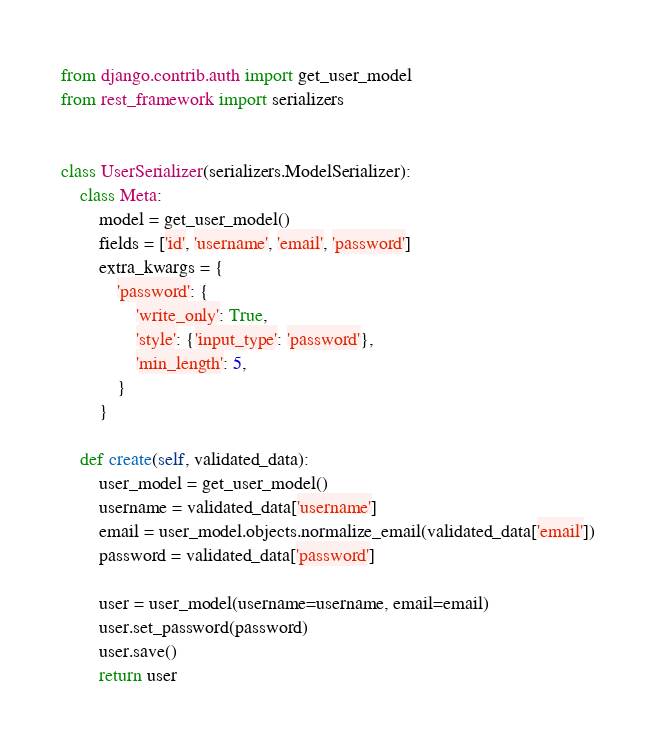Convert code to text. <code><loc_0><loc_0><loc_500><loc_500><_Python_>from django.contrib.auth import get_user_model
from rest_framework import serializers


class UserSerializer(serializers.ModelSerializer):
    class Meta:
        model = get_user_model()
        fields = ['id', 'username', 'email', 'password']
        extra_kwargs = {
            'password': {
                'write_only': True,
                'style': {'input_type': 'password'},
                'min_length': 5,
            }
        }

    def create(self, validated_data):
        user_model = get_user_model()
        username = validated_data['username']
        email = user_model.objects.normalize_email(validated_data['email'])
        password = validated_data['password']

        user = user_model(username=username, email=email)
        user.set_password(password)
        user.save()
        return user
</code> 